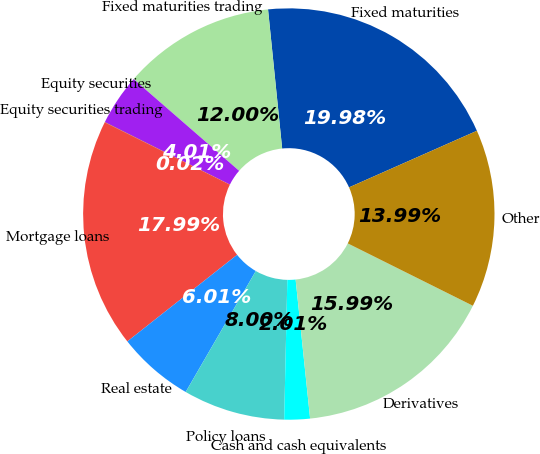<chart> <loc_0><loc_0><loc_500><loc_500><pie_chart><fcel>Fixed maturities<fcel>Fixed maturities trading<fcel>Equity securities<fcel>Equity securities trading<fcel>Mortgage loans<fcel>Real estate<fcel>Policy loans<fcel>Cash and cash equivalents<fcel>Derivatives<fcel>Other<nl><fcel>19.98%<fcel>12.0%<fcel>4.01%<fcel>0.02%<fcel>17.99%<fcel>6.01%<fcel>8.0%<fcel>2.01%<fcel>15.99%<fcel>13.99%<nl></chart> 